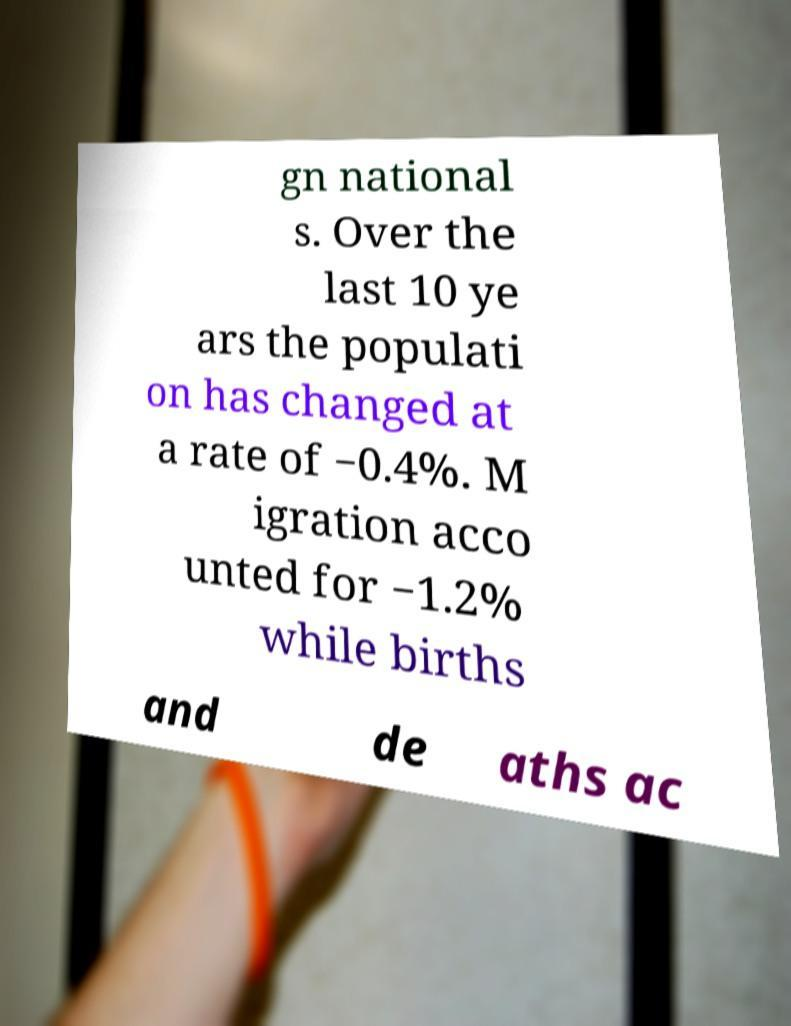For documentation purposes, I need the text within this image transcribed. Could you provide that? gn national s. Over the last 10 ye ars the populati on has changed at a rate of −0.4%. M igration acco unted for −1.2% while births and de aths ac 